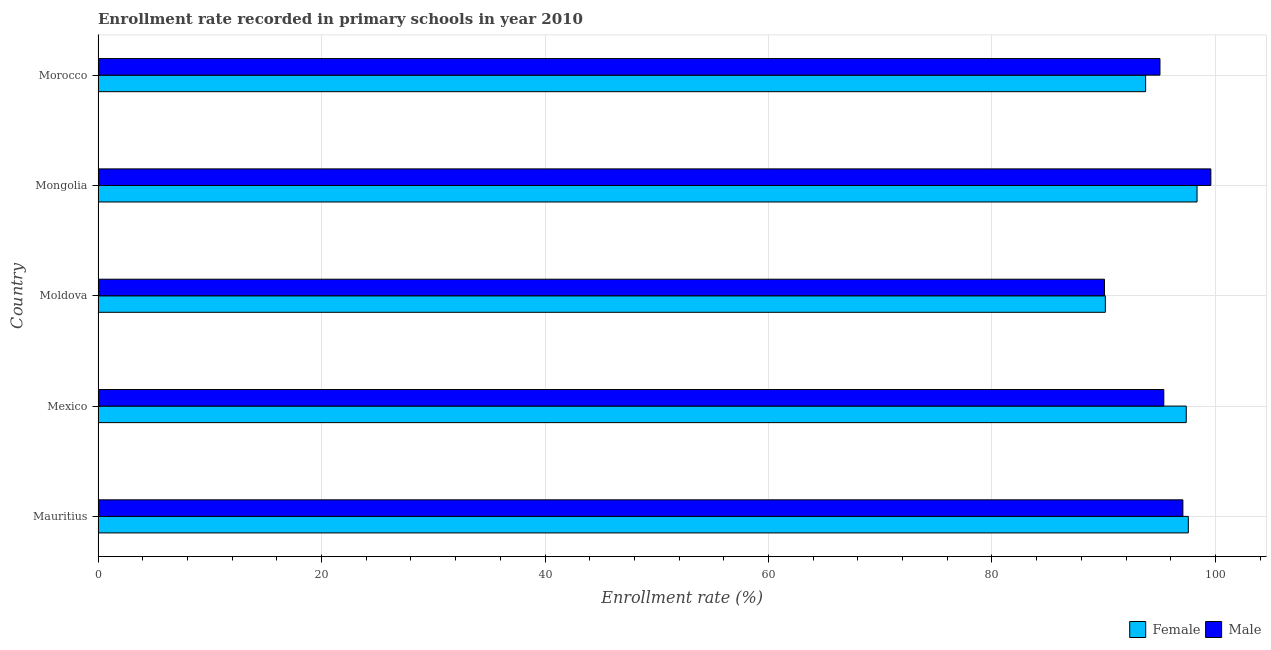How many different coloured bars are there?
Your answer should be compact. 2. Are the number of bars per tick equal to the number of legend labels?
Make the answer very short. Yes. How many bars are there on the 2nd tick from the top?
Provide a succinct answer. 2. How many bars are there on the 2nd tick from the bottom?
Provide a succinct answer. 2. What is the label of the 5th group of bars from the top?
Offer a terse response. Mauritius. In how many cases, is the number of bars for a given country not equal to the number of legend labels?
Your answer should be compact. 0. What is the enrollment rate of male students in Morocco?
Make the answer very short. 95.03. Across all countries, what is the maximum enrollment rate of female students?
Give a very brief answer. 98.35. Across all countries, what is the minimum enrollment rate of female students?
Provide a succinct answer. 90.14. In which country was the enrollment rate of male students maximum?
Your response must be concise. Mongolia. In which country was the enrollment rate of male students minimum?
Ensure brevity in your answer.  Moldova. What is the total enrollment rate of male students in the graph?
Offer a very short reply. 477.15. What is the difference between the enrollment rate of male students in Mexico and that in Mongolia?
Provide a succinct answer. -4.21. What is the difference between the enrollment rate of female students in Mongolia and the enrollment rate of male students in Mexico?
Provide a succinct answer. 2.98. What is the average enrollment rate of female students per country?
Give a very brief answer. 95.44. What is the difference between the enrollment rate of male students and enrollment rate of female students in Mauritius?
Your answer should be very brief. -0.48. In how many countries, is the enrollment rate of male students greater than 52 %?
Offer a terse response. 5. What is the ratio of the enrollment rate of male students in Moldova to that in Morocco?
Offer a terse response. 0.95. Is the enrollment rate of male students in Mexico less than that in Mongolia?
Ensure brevity in your answer.  Yes. Is the difference between the enrollment rate of female students in Moldova and Morocco greater than the difference between the enrollment rate of male students in Moldova and Morocco?
Your answer should be compact. Yes. What is the difference between the highest and the second highest enrollment rate of male students?
Ensure brevity in your answer.  2.5. What is the difference between the highest and the lowest enrollment rate of male students?
Provide a short and direct response. 9.52. In how many countries, is the enrollment rate of male students greater than the average enrollment rate of male students taken over all countries?
Give a very brief answer. 2. What does the 1st bar from the top in Morocco represents?
Ensure brevity in your answer.  Male. What is the difference between two consecutive major ticks on the X-axis?
Keep it short and to the point. 20. Does the graph contain grids?
Offer a very short reply. Yes. Where does the legend appear in the graph?
Give a very brief answer. Bottom right. How are the legend labels stacked?
Your answer should be compact. Horizontal. What is the title of the graph?
Provide a succinct answer. Enrollment rate recorded in primary schools in year 2010. What is the label or title of the X-axis?
Your response must be concise. Enrollment rate (%). What is the label or title of the Y-axis?
Offer a terse response. Country. What is the Enrollment rate (%) of Female in Mauritius?
Provide a short and direct response. 97.57. What is the Enrollment rate (%) of Male in Mauritius?
Your answer should be compact. 97.08. What is the Enrollment rate (%) of Female in Mexico?
Provide a succinct answer. 97.39. What is the Enrollment rate (%) in Male in Mexico?
Your answer should be very brief. 95.38. What is the Enrollment rate (%) in Female in Moldova?
Provide a short and direct response. 90.14. What is the Enrollment rate (%) in Male in Moldova?
Your response must be concise. 90.07. What is the Enrollment rate (%) in Female in Mongolia?
Make the answer very short. 98.35. What is the Enrollment rate (%) in Male in Mongolia?
Offer a terse response. 99.59. What is the Enrollment rate (%) in Female in Morocco?
Keep it short and to the point. 93.75. What is the Enrollment rate (%) in Male in Morocco?
Make the answer very short. 95.03. Across all countries, what is the maximum Enrollment rate (%) in Female?
Make the answer very short. 98.35. Across all countries, what is the maximum Enrollment rate (%) in Male?
Your answer should be very brief. 99.59. Across all countries, what is the minimum Enrollment rate (%) in Female?
Offer a terse response. 90.14. Across all countries, what is the minimum Enrollment rate (%) of Male?
Your answer should be very brief. 90.07. What is the total Enrollment rate (%) in Female in the graph?
Ensure brevity in your answer.  477.2. What is the total Enrollment rate (%) of Male in the graph?
Make the answer very short. 477.15. What is the difference between the Enrollment rate (%) in Female in Mauritius and that in Mexico?
Ensure brevity in your answer.  0.18. What is the difference between the Enrollment rate (%) in Male in Mauritius and that in Mexico?
Provide a short and direct response. 1.71. What is the difference between the Enrollment rate (%) of Female in Mauritius and that in Moldova?
Your response must be concise. 7.42. What is the difference between the Enrollment rate (%) of Male in Mauritius and that in Moldova?
Your response must be concise. 7.02. What is the difference between the Enrollment rate (%) in Female in Mauritius and that in Mongolia?
Offer a very short reply. -0.78. What is the difference between the Enrollment rate (%) in Male in Mauritius and that in Mongolia?
Provide a short and direct response. -2.5. What is the difference between the Enrollment rate (%) of Female in Mauritius and that in Morocco?
Your response must be concise. 3.82. What is the difference between the Enrollment rate (%) in Male in Mauritius and that in Morocco?
Make the answer very short. 2.05. What is the difference between the Enrollment rate (%) of Female in Mexico and that in Moldova?
Your response must be concise. 7.24. What is the difference between the Enrollment rate (%) of Male in Mexico and that in Moldova?
Offer a very short reply. 5.31. What is the difference between the Enrollment rate (%) of Female in Mexico and that in Mongolia?
Ensure brevity in your answer.  -0.97. What is the difference between the Enrollment rate (%) in Male in Mexico and that in Mongolia?
Your answer should be compact. -4.21. What is the difference between the Enrollment rate (%) in Female in Mexico and that in Morocco?
Your answer should be very brief. 3.64. What is the difference between the Enrollment rate (%) of Male in Mexico and that in Morocco?
Ensure brevity in your answer.  0.34. What is the difference between the Enrollment rate (%) in Female in Moldova and that in Mongolia?
Your answer should be compact. -8.21. What is the difference between the Enrollment rate (%) in Male in Moldova and that in Mongolia?
Offer a very short reply. -9.52. What is the difference between the Enrollment rate (%) in Female in Moldova and that in Morocco?
Your answer should be compact. -3.61. What is the difference between the Enrollment rate (%) in Male in Moldova and that in Morocco?
Your answer should be very brief. -4.97. What is the difference between the Enrollment rate (%) in Female in Mongolia and that in Morocco?
Offer a very short reply. 4.6. What is the difference between the Enrollment rate (%) of Male in Mongolia and that in Morocco?
Keep it short and to the point. 4.55. What is the difference between the Enrollment rate (%) in Female in Mauritius and the Enrollment rate (%) in Male in Mexico?
Offer a terse response. 2.19. What is the difference between the Enrollment rate (%) of Female in Mauritius and the Enrollment rate (%) of Male in Moldova?
Keep it short and to the point. 7.5. What is the difference between the Enrollment rate (%) of Female in Mauritius and the Enrollment rate (%) of Male in Mongolia?
Keep it short and to the point. -2.02. What is the difference between the Enrollment rate (%) of Female in Mauritius and the Enrollment rate (%) of Male in Morocco?
Make the answer very short. 2.54. What is the difference between the Enrollment rate (%) of Female in Mexico and the Enrollment rate (%) of Male in Moldova?
Offer a terse response. 7.32. What is the difference between the Enrollment rate (%) of Female in Mexico and the Enrollment rate (%) of Male in Mongolia?
Your response must be concise. -2.2. What is the difference between the Enrollment rate (%) in Female in Mexico and the Enrollment rate (%) in Male in Morocco?
Your response must be concise. 2.35. What is the difference between the Enrollment rate (%) of Female in Moldova and the Enrollment rate (%) of Male in Mongolia?
Provide a short and direct response. -9.44. What is the difference between the Enrollment rate (%) of Female in Moldova and the Enrollment rate (%) of Male in Morocco?
Offer a very short reply. -4.89. What is the difference between the Enrollment rate (%) of Female in Mongolia and the Enrollment rate (%) of Male in Morocco?
Provide a short and direct response. 3.32. What is the average Enrollment rate (%) in Female per country?
Your response must be concise. 95.44. What is the average Enrollment rate (%) in Male per country?
Offer a very short reply. 95.43. What is the difference between the Enrollment rate (%) in Female and Enrollment rate (%) in Male in Mauritius?
Give a very brief answer. 0.48. What is the difference between the Enrollment rate (%) of Female and Enrollment rate (%) of Male in Mexico?
Ensure brevity in your answer.  2.01. What is the difference between the Enrollment rate (%) in Female and Enrollment rate (%) in Male in Moldova?
Give a very brief answer. 0.08. What is the difference between the Enrollment rate (%) in Female and Enrollment rate (%) in Male in Mongolia?
Ensure brevity in your answer.  -1.23. What is the difference between the Enrollment rate (%) of Female and Enrollment rate (%) of Male in Morocco?
Provide a short and direct response. -1.28. What is the ratio of the Enrollment rate (%) in Male in Mauritius to that in Mexico?
Keep it short and to the point. 1.02. What is the ratio of the Enrollment rate (%) of Female in Mauritius to that in Moldova?
Your answer should be compact. 1.08. What is the ratio of the Enrollment rate (%) of Male in Mauritius to that in Moldova?
Give a very brief answer. 1.08. What is the ratio of the Enrollment rate (%) in Male in Mauritius to that in Mongolia?
Offer a very short reply. 0.97. What is the ratio of the Enrollment rate (%) in Female in Mauritius to that in Morocco?
Provide a succinct answer. 1.04. What is the ratio of the Enrollment rate (%) of Male in Mauritius to that in Morocco?
Offer a very short reply. 1.02. What is the ratio of the Enrollment rate (%) in Female in Mexico to that in Moldova?
Keep it short and to the point. 1.08. What is the ratio of the Enrollment rate (%) in Male in Mexico to that in Moldova?
Provide a short and direct response. 1.06. What is the ratio of the Enrollment rate (%) in Female in Mexico to that in Mongolia?
Your response must be concise. 0.99. What is the ratio of the Enrollment rate (%) of Male in Mexico to that in Mongolia?
Make the answer very short. 0.96. What is the ratio of the Enrollment rate (%) in Female in Mexico to that in Morocco?
Offer a very short reply. 1.04. What is the ratio of the Enrollment rate (%) of Female in Moldova to that in Mongolia?
Make the answer very short. 0.92. What is the ratio of the Enrollment rate (%) in Male in Moldova to that in Mongolia?
Offer a very short reply. 0.9. What is the ratio of the Enrollment rate (%) of Female in Moldova to that in Morocco?
Your answer should be very brief. 0.96. What is the ratio of the Enrollment rate (%) in Male in Moldova to that in Morocco?
Offer a terse response. 0.95. What is the ratio of the Enrollment rate (%) in Female in Mongolia to that in Morocco?
Your response must be concise. 1.05. What is the ratio of the Enrollment rate (%) of Male in Mongolia to that in Morocco?
Provide a short and direct response. 1.05. What is the difference between the highest and the second highest Enrollment rate (%) in Female?
Your answer should be compact. 0.78. What is the difference between the highest and the second highest Enrollment rate (%) of Male?
Provide a succinct answer. 2.5. What is the difference between the highest and the lowest Enrollment rate (%) in Female?
Offer a very short reply. 8.21. What is the difference between the highest and the lowest Enrollment rate (%) in Male?
Keep it short and to the point. 9.52. 